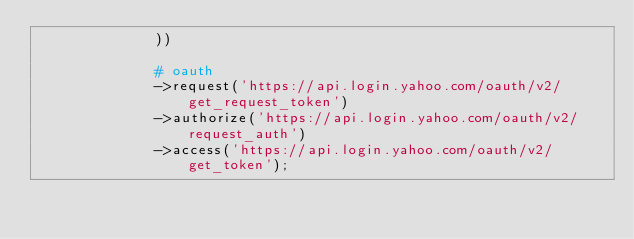Convert code to text. <code><loc_0><loc_0><loc_500><loc_500><_PHP_>              ))

              # oauth
              ->request('https://api.login.yahoo.com/oauth/v2/get_request_token')
              ->authorize('https://api.login.yahoo.com/oauth/v2/request_auth')
              ->access('https://api.login.yahoo.com/oauth/v2/get_token');
</code> 